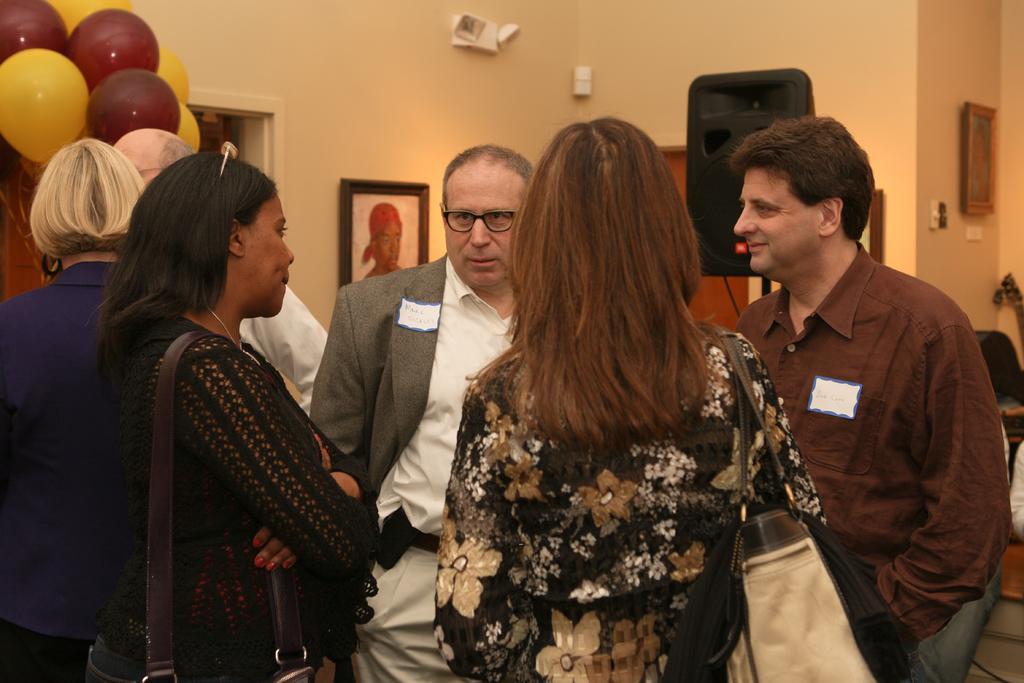Please provide a concise description of this image. In this image, we can see a group of people are standing. Here we can see two women are wearing bags. In the background, we can see wall, speaker, frames, balloons, brown objects and few things. 